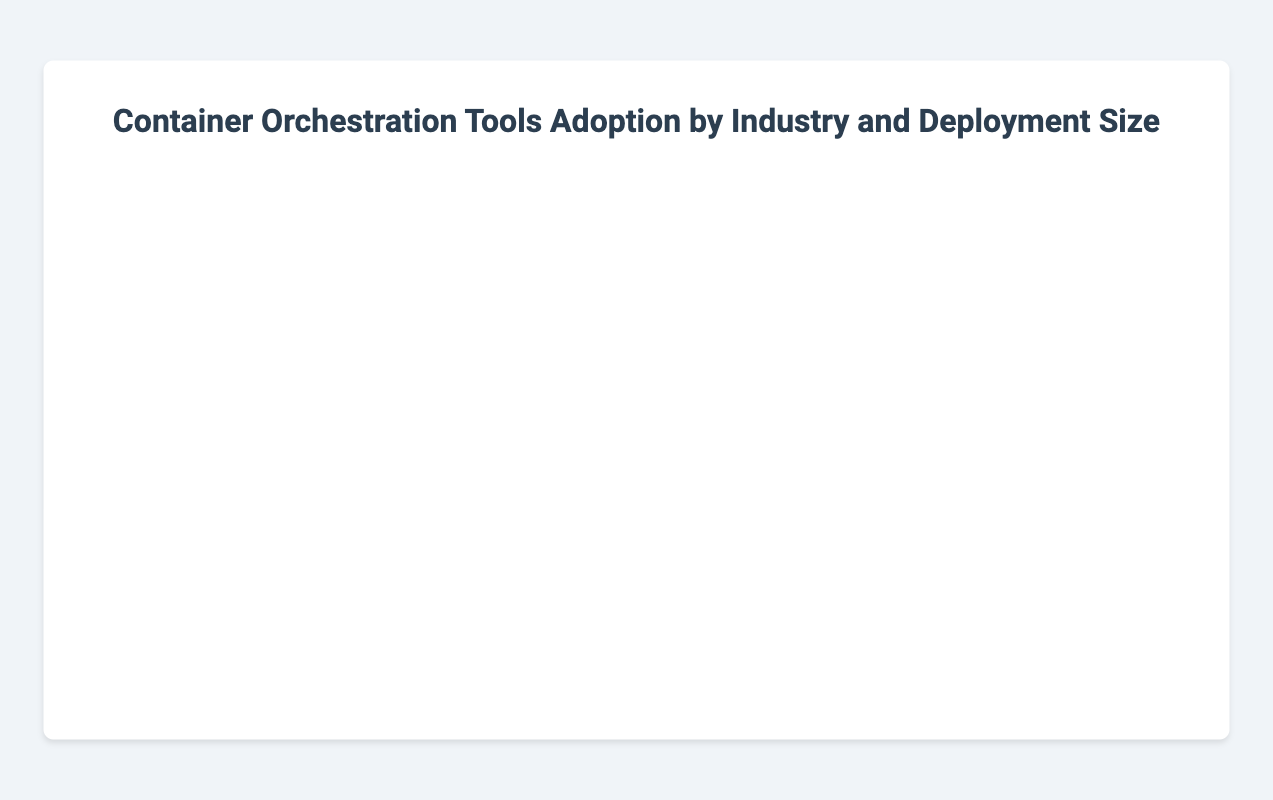What is the adoption rate of Kubernetes in the Finance industry for large deployments? To find this, look for the bubble that represents the Finance industry with a large deployment size and see its position on the x-axis. The bubble for large deployments in Finance is around the highest x-value. Checking the exact value, it is 90%.
Answer: 90% Which deployment size has the highest adoption rate in the Retail industry? Locate the bubbles corresponding to the Retail industry and compare their x-axis values for small, medium, and large deployment sizes. The large deployment size has the highest adoption rate at 95%.
Answer: Large How many users are using ECS in medium-sized deployments in the E-commerce industry? Find the bubble that represents the E-commerce industry with a medium deployment using ECS. The radius of this bubble indicates the number of users, and since the radius is 'r' and r = users/5, r is 50. Therefore, number of users is 50 * 5 = 250.
Answer: 250 Which industry has the smallest number of users using Docker Swarm? Identify the bubbles corresponding to Docker Swarm across all industries by their color. Observe their radius. The smallest bubble is in the Education industry with a radius of 10 (50 users).
Answer: Education Compare the adoption rates of Kubernetes across all industries for small deployment sizes. What is the largest and smallest adoption rate you observe? Check the x-axis values of bubbles with small deployment sizes across all industries and identify those using Kubernetes. E-commerce has the highest at 75%, and there are no other small deployment sizes using Kubernetes relevant for comparison.
Answer: Largest: 75%, Smallest: N/A What is the average adoption rate of Docker Swarm across all its deployments? First, find the x-axis values for all bubbles using Docker Swarm. These are 50 (Finance, small), 40 (Healthcare, small), and 35 (Education, small). Add these values: 50 + 40 + 35 = 125. Since there are 3 data points, average is 125 / 3 ≈ 41.67
Answer: 41.67% Which tool has the highest adoption rate in the Healthcare industry for medium deployments? Locate the bubble for Healthcare with medium deployment size, and observe the tool and x-axis value. The tool is ECS with an adoption rate of 55%.
Answer: ECS Between Finance and Retail industries, which has the highest adoption rate for Kubernetes with medium deployment sizes? Compare the x-axis values of Finance and Retail bubbles with medium deployment sizes using Kubernetes. Finance has an adoption rate of 70%, and Retail has 75%, so Retail is higher.
Answer: Retail In the E-commerce industry, what is the difference in adoption rates between Kubernetes for large and small deployments? Identify the x-axis values for Kubernetes in large and small deployments in E-commerce. Large is 85% and small is 75%. Difference: 85% - 75% = 10%
Answer: 10% What is the most commonly adopted container orchestration tool across all industries for large deployments? Look at the tool labels of all bubbles representing large deployments to count the occurrences. Kubernetes is used in E-commerce, Finance, Healthcare, Retail, and Education industries for large deployments.
Answer: Kubernetes 